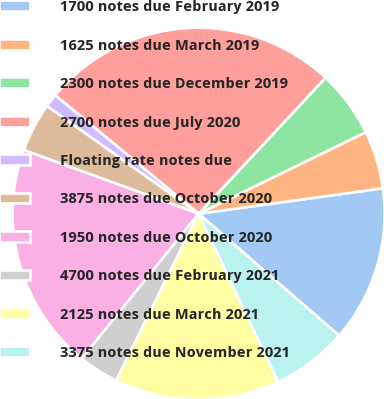<chart> <loc_0><loc_0><loc_500><loc_500><pie_chart><fcel>1700 notes due February 2019<fcel>1625 notes due March 2019<fcel>2300 notes due December 2019<fcel>2700 notes due July 2020<fcel>Floating rate notes due<fcel>3875 notes due October 2020<fcel>1950 notes due October 2020<fcel>4700 notes due February 2021<fcel>2125 notes due March 2021<fcel>3375 notes due November 2021<nl><fcel>13.56%<fcel>5.04%<fcel>5.82%<fcel>25.95%<fcel>1.17%<fcel>4.27%<fcel>19.76%<fcel>3.49%<fcel>14.34%<fcel>6.59%<nl></chart> 